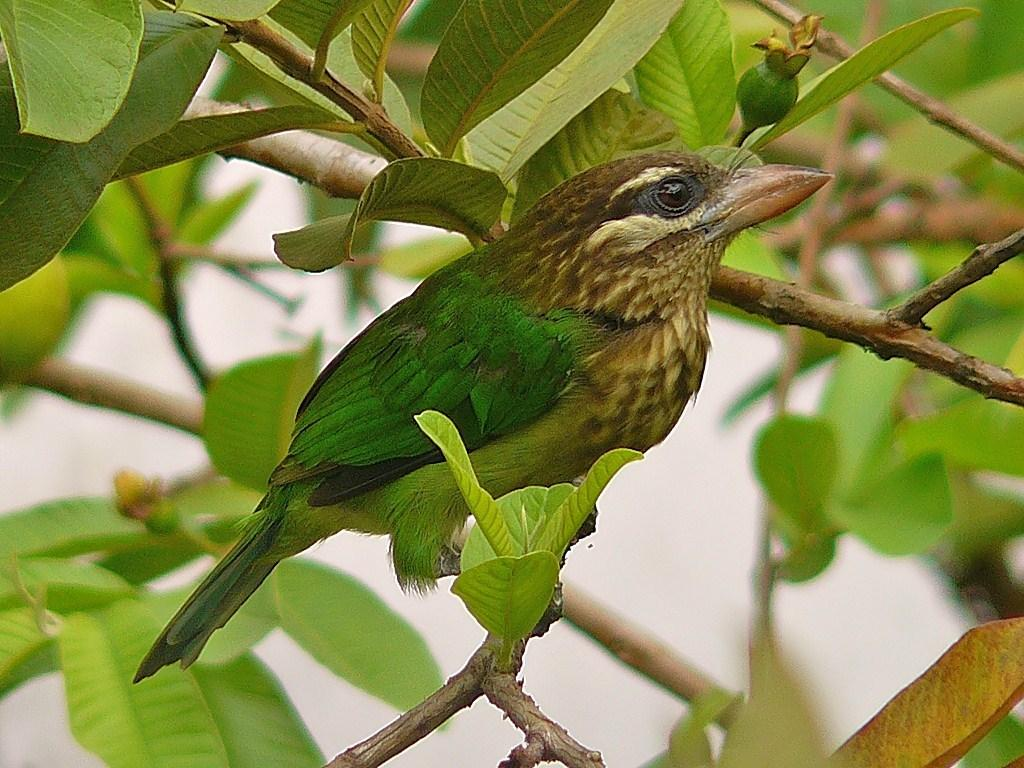What type of animal can be seen in the image? There is a bird in the image. Where is the bird located? The bird is standing on a branch. What is the branch a part of? The branch is part of a tree. What can be seen in the background of the image? There are leaves visible in the background of the image. What type of box is the bird using as a prison in the image? There is no box or prison present in the image; the bird is standing on a branch of a tree. 